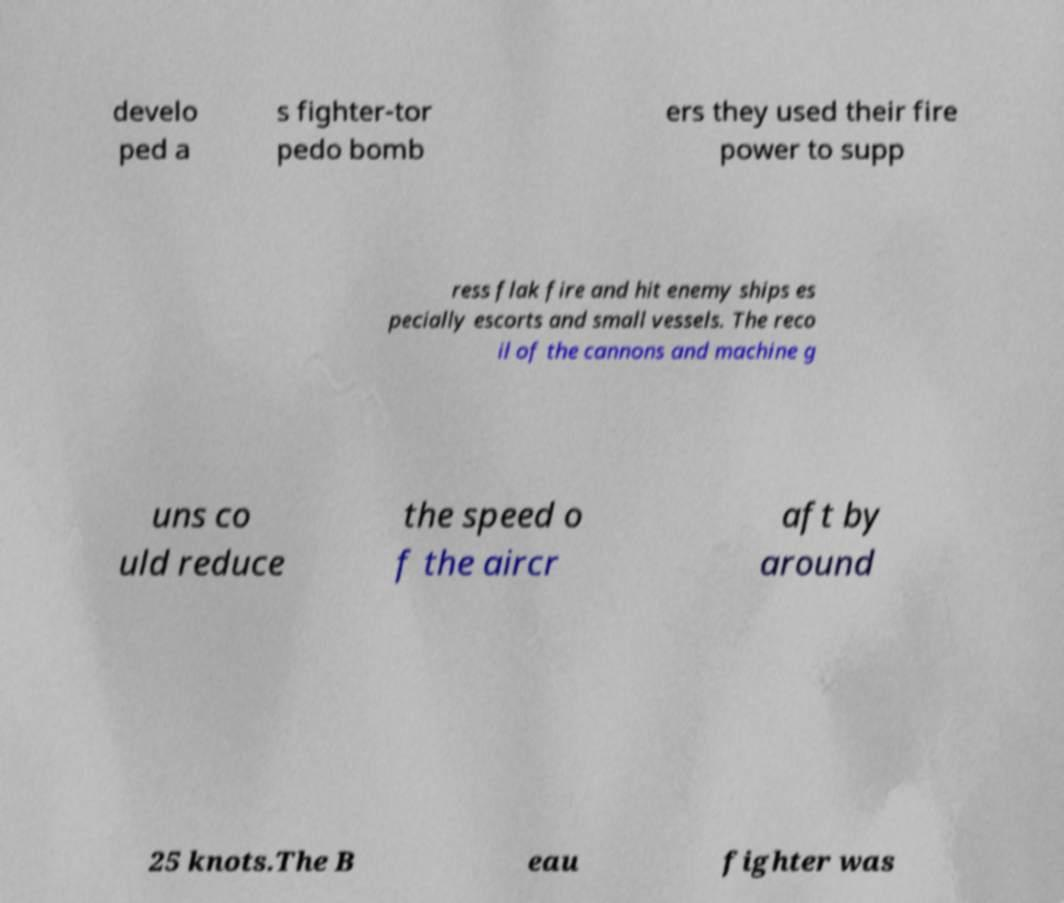Can you accurately transcribe the text from the provided image for me? develo ped a s fighter-tor pedo bomb ers they used their fire power to supp ress flak fire and hit enemy ships es pecially escorts and small vessels. The reco il of the cannons and machine g uns co uld reduce the speed o f the aircr aft by around 25 knots.The B eau fighter was 